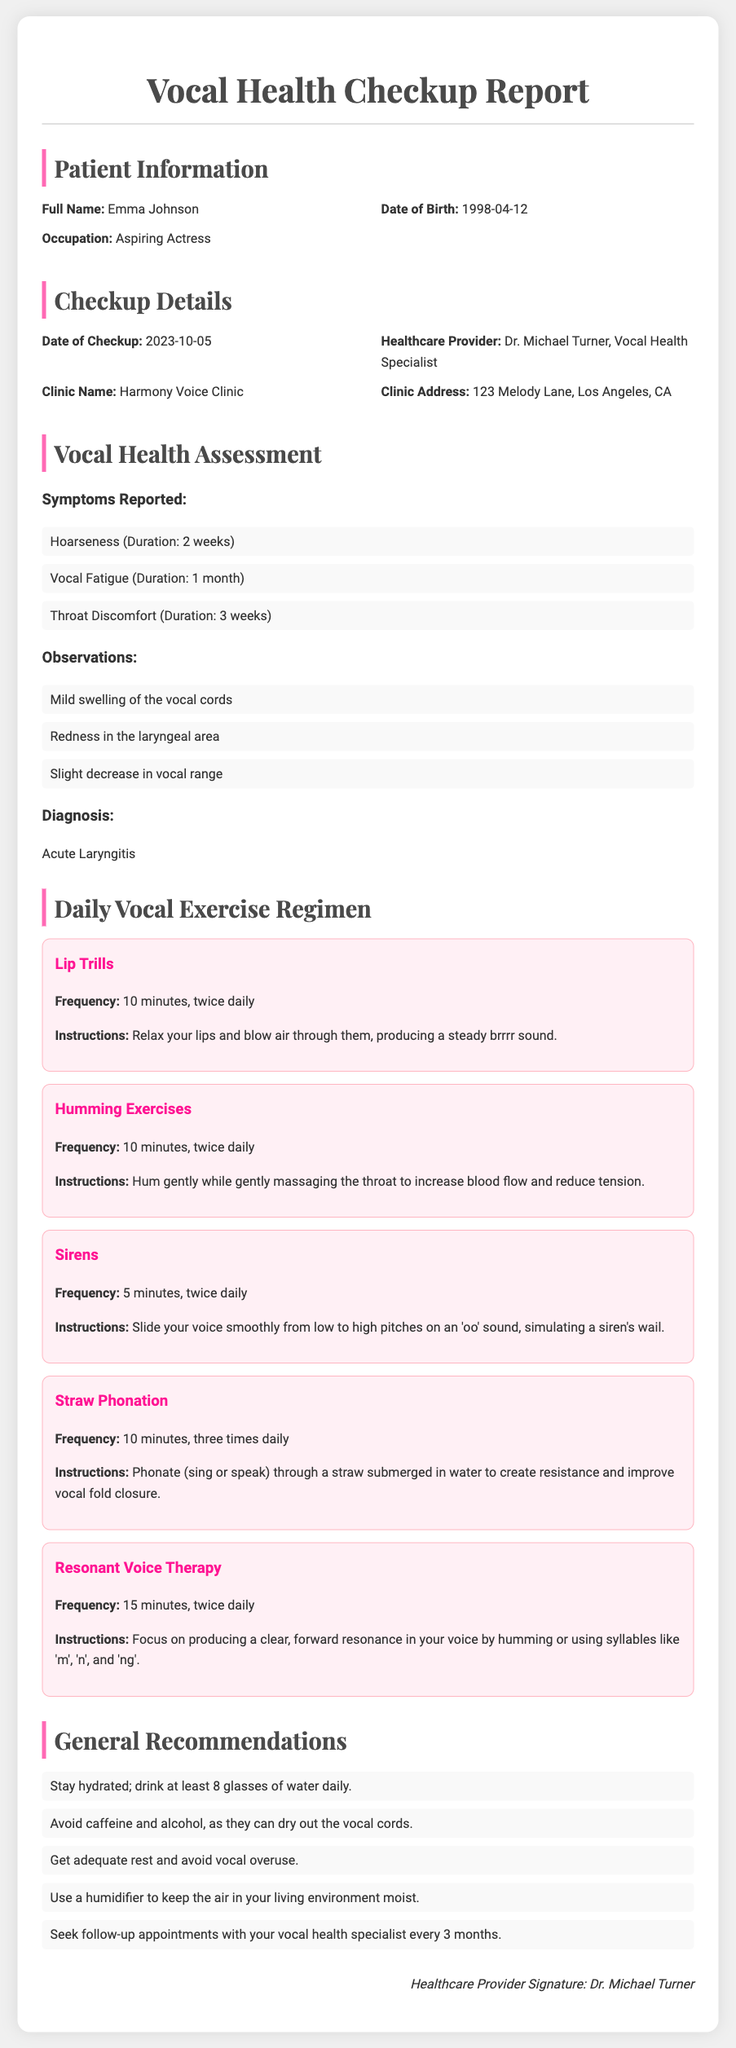What is the patient's full name? The patient's full name is provided in the patient information section of the document.
Answer: Emma Johnson What is the date of the checkup? The date of the checkup is mentioned under the checkup details section.
Answer: 2023-10-05 Who is the healthcare provider? The healthcare provider's name is listed in the checkup details.
Answer: Dr. Michael Turner, Vocal Health Specialist What is the main diagnosis? The diagnosis is stated in the vocal health assessment section of the report.
Answer: Acute Laryngitis How long has the patient experienced vocal fatigue? The duration of vocal fatigue is specified in the symptoms reported section.
Answer: 1 month What is the frequency of the lip trills exercise? The frequency is detailed in the daily vocal exercise regimen section.
Answer: 10 minutes, twice daily What specific fluid intake is recommended? The recommendations mention hydration details that specify fluid intake.
Answer: 8 glasses of water What is the primary purpose of straw phonation? The exercise instructions provide insight into the purpose of straw phonation in vocal health.
Answer: Improve vocal fold closure How often should follow-up appointments occur? The recommendation for follow-up appointments is specified under general recommendations.
Answer: Every 3 months 